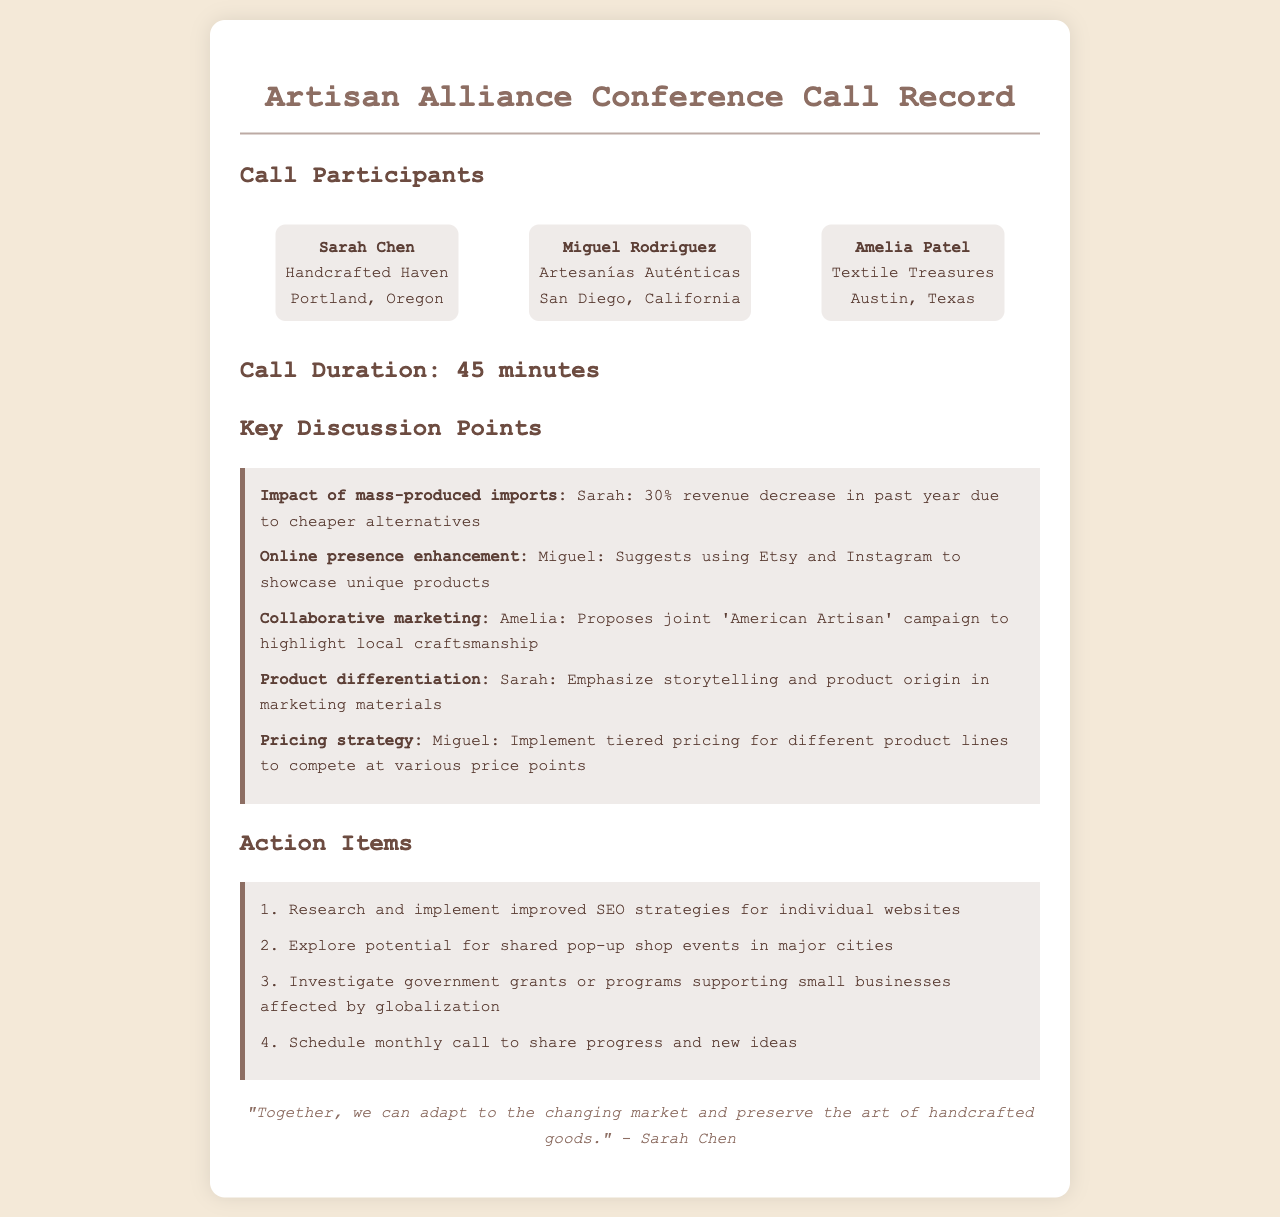What was the main reason for the revenue decrease mentioned? Sarah mentioned a 30% revenue decrease due to cheaper alternatives in mass-produced imports.
Answer: cheaper alternatives Which platform did Miguel suggest for showcasing unique products? Miguel suggested using Etsy and Instagram for this purpose.
Answer: Etsy and Instagram What action item involves researching online visibility? The first action item pertains to improving SEO strategies for websites.
Answer: improved SEO strategies How long was the conference call? The duration of the call is specified as 45 minutes.
Answer: 45 minutes What is the name of Amelia's business? Amelia Patel's business is named Textile Treasures.
Answer: Textile Treasures What campaign did Amelia propose to highlight local craftsmanship? Amelia proposed a joint 'American Artisan' campaign.
Answer: 'American Artisan' campaign What pricing strategy did Miguel suggest? Miguel suggested implementing tiered pricing for different product lines.
Answer: tiered pricing Who closed the call with a quote? The call was closed by Sarah Chen with a quote about adapting to the market.
Answer: Sarah Chen 